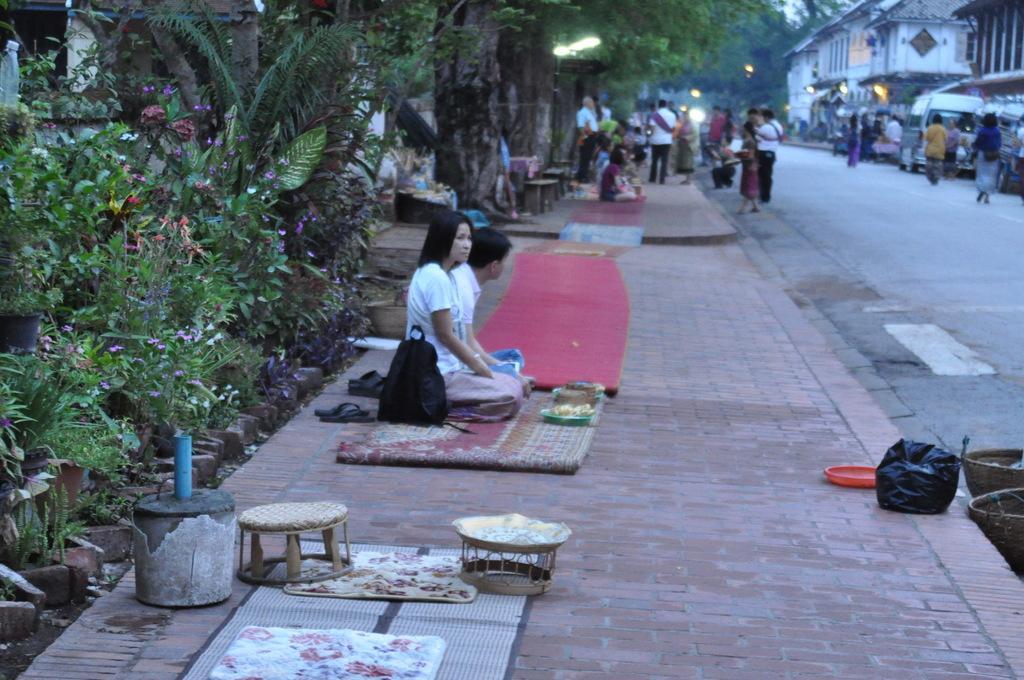Can you describe this image briefly? This is the picture of a street where we have some buildings to the left side and on the footpath we have some people sitting on the floor and some things in front of them and behind them there are some plants. 